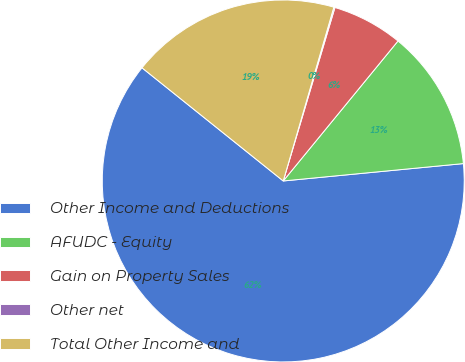<chart> <loc_0><loc_0><loc_500><loc_500><pie_chart><fcel>Other Income and Deductions<fcel>AFUDC - Equity<fcel>Gain on Property Sales<fcel>Other net<fcel>Total Other Income and<nl><fcel>62.28%<fcel>12.54%<fcel>6.32%<fcel>0.1%<fcel>18.76%<nl></chart> 